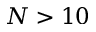<formula> <loc_0><loc_0><loc_500><loc_500>N > 1 0</formula> 